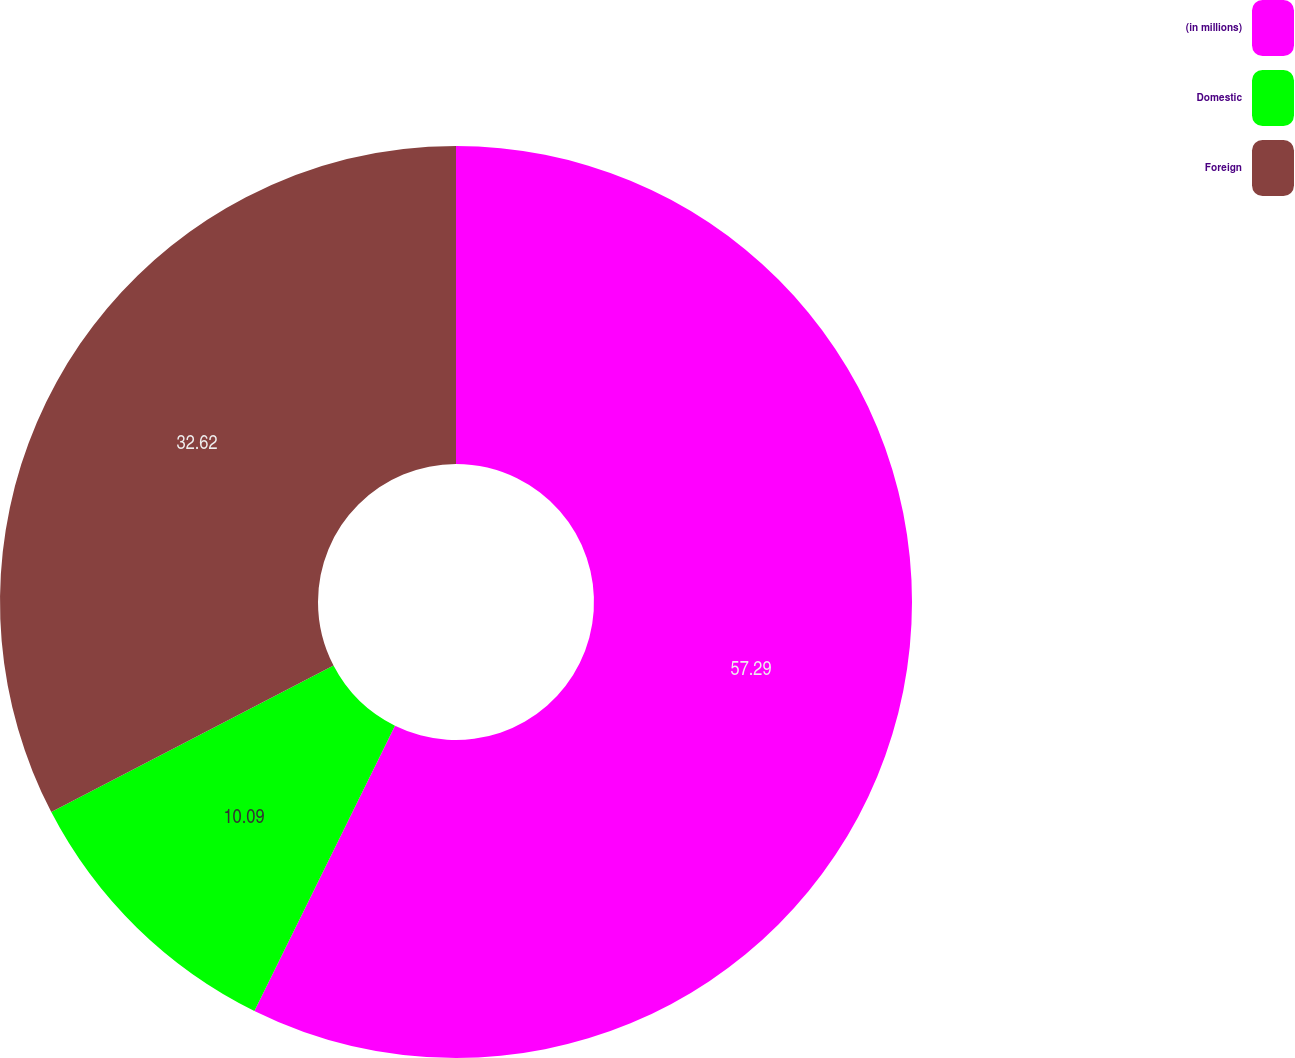Convert chart to OTSL. <chart><loc_0><loc_0><loc_500><loc_500><pie_chart><fcel>(in millions)<fcel>Domestic<fcel>Foreign<nl><fcel>57.29%<fcel>10.09%<fcel>32.62%<nl></chart> 